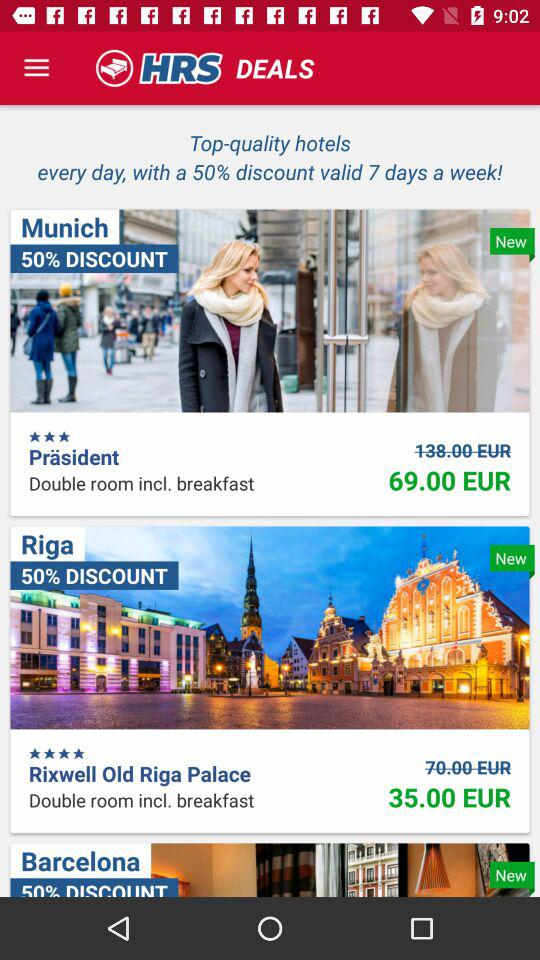In which place is the "Präsident" hotel located? The "Präsident" hotel is located in Munich. 